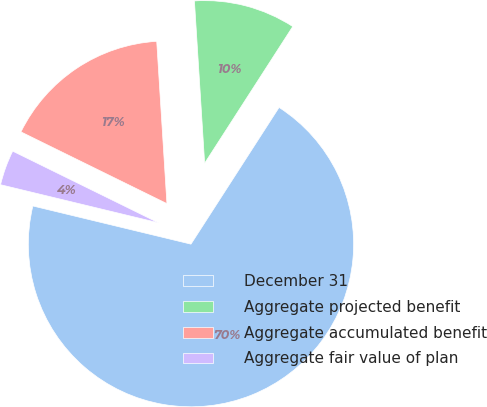<chart> <loc_0><loc_0><loc_500><loc_500><pie_chart><fcel>December 31<fcel>Aggregate projected benefit<fcel>Aggregate accumulated benefit<fcel>Aggregate fair value of plan<nl><fcel>69.66%<fcel>10.11%<fcel>16.73%<fcel>3.5%<nl></chart> 